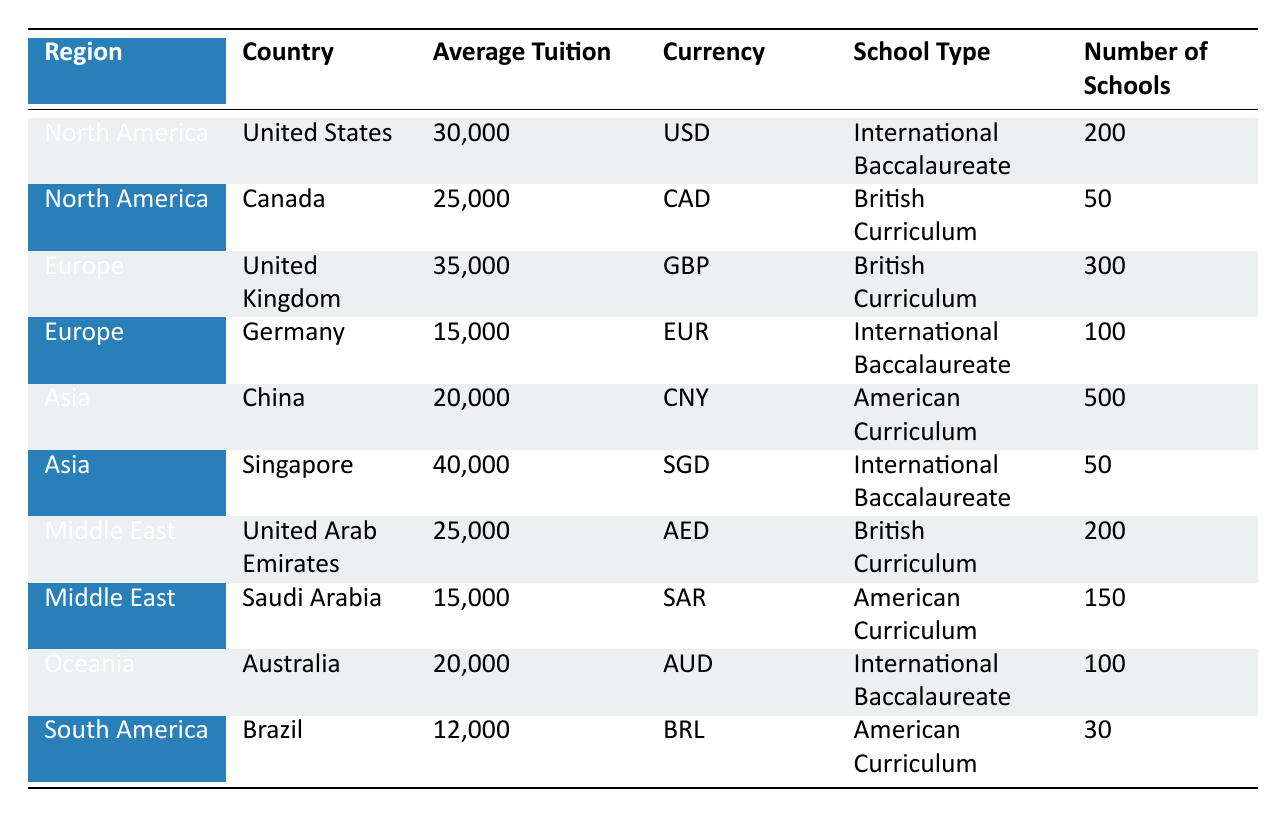What is the average tuition fee in the United States? The table shows that the average tuition fee in the United States is listed as 30,000 USD.
Answer: 30,000 USD Which country in Europe has the highest average tuition fee? By comparing the average tuition fees in Europe, the United Kingdom has the highest fee at 35,000 GBP.
Answer: United Kingdom How many schools offer the American Curriculum in China? The table indicates that there are 500 schools offering the American Curriculum in China.
Answer: 500 schools What is the total number of schools in the Middle East? To find the total, add the number of schools in the United Arab Emirates (200) and Saudi Arabia (150), which gives 200 + 150 = 350 schools.
Answer: 350 schools Which region has the lowest average tuition fee? The average tuition fee for South America is 12,000 BRL, which is lower than any fee in the other regions listed.
Answer: South America What is the average tuition fee for the International Baccalaureate schools in Oceania? The table only shows one entry for Oceania, which is Australia with an Average Tuition of 20,000 AUD for International Baccalaureate schools. Hence, the average is 20,000 AUD.
Answer: 20,000 AUD Is the average tuition fee in Saudi Arabia more than in Germany? The average tuition fee in Saudi Arabia is 15,000 SAR, while in Germany it is 15,000 EUR, making them equal if converted but currently not more, so the fact is false.
Answer: No What is the difference in average tuition fees between Canada and Singapore? The average fee in Canada is 25,000 CAD, and in Singapore, it is 40,000 SGD. To find the difference: 40,000 - 25,000 = 15,000.
Answer: 15,000 How many countries have an average tuition fee of 25,000 or more? The countries with at least 25,000 in average tuition are the United States, United Kingdom, Singapore, and the United Arab Emirates. This totals to 4 countries.
Answer: 4 countries What percentage of schools in Asia offer the American Curriculum? There are 500 schools in China offering the American Curriculum and none in Singapore, resulting in a total of 500 schools. The total number of schools in Asia is 500 (China) + 50 (Singapore) = 550. The percentage is (500/550) * 100 = 90.91%.
Answer: 90.91% 